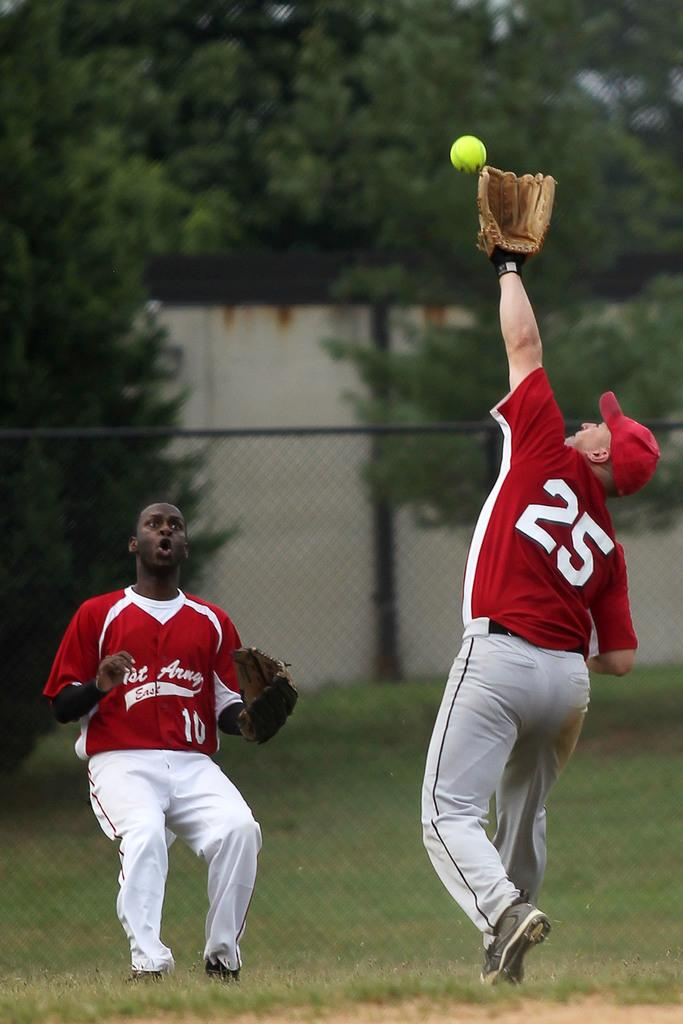<image>
Write a terse but informative summary of the picture. a man in a 25 number jersey reaches to catch a ball 